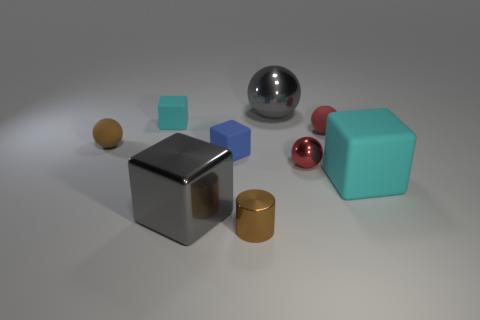What is the texture of the objects? Do they appear matte or shiny? Most of the objects have a shiny texture that reflects light, suggesting they are possibly made of materials like metal or polished stone. The spheres and cylinder have a high shine to them, while the cubes have a slightly subdued shine, but still reflective. Is there any object that stands out from the rest? Yes, the large silver sphere stands out due to its high reflectiveness and contrast against the matte surface on which all objects are placed. 